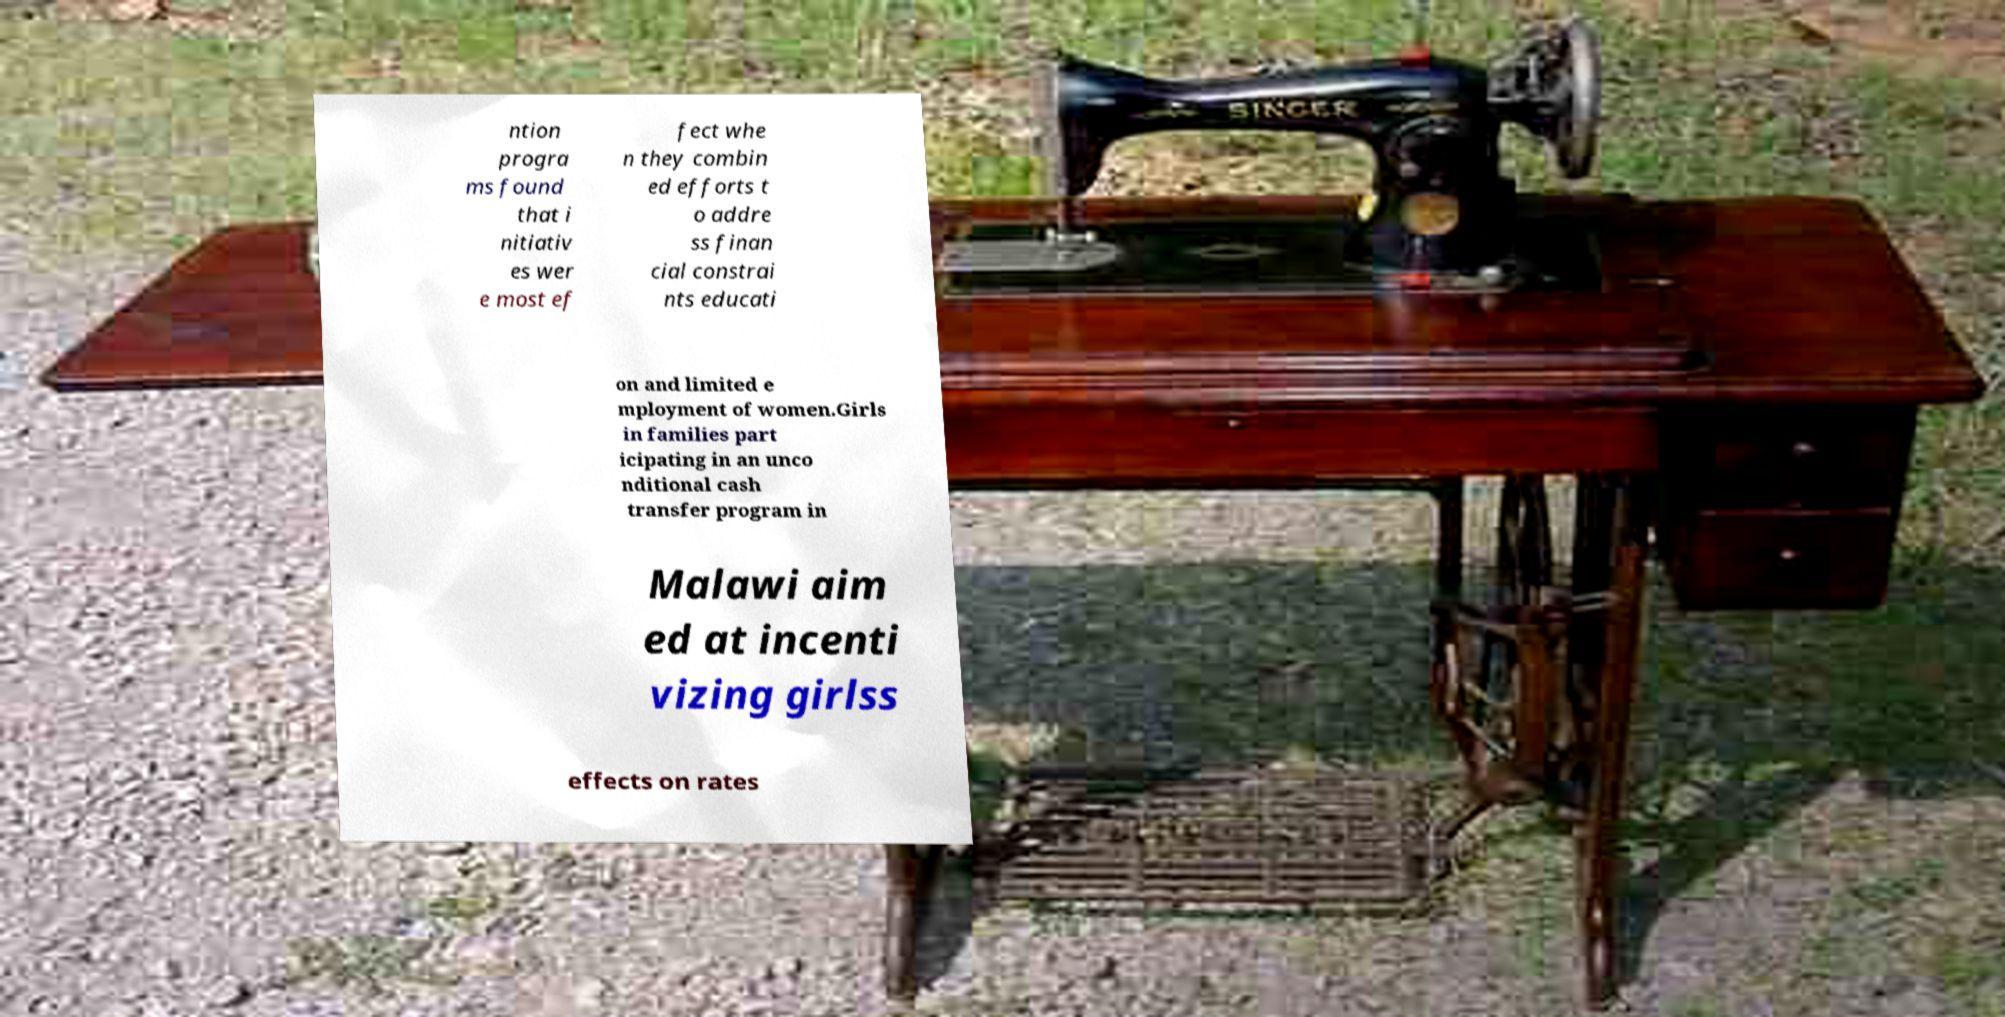What messages or text are displayed in this image? I need them in a readable, typed format. ntion progra ms found that i nitiativ es wer e most ef fect whe n they combin ed efforts t o addre ss finan cial constrai nts educati on and limited e mployment of women.Girls in families part icipating in an unco nditional cash transfer program in Malawi aim ed at incenti vizing girlss effects on rates 